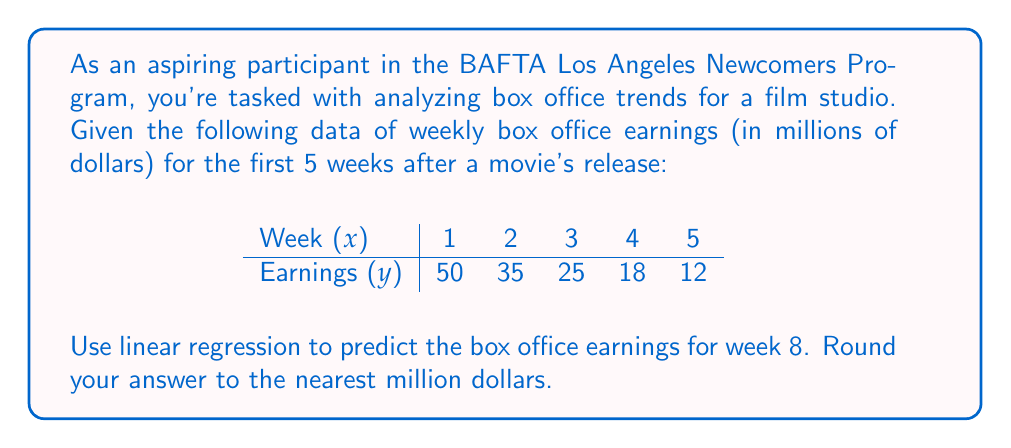Teach me how to tackle this problem. To solve this problem, we'll use linear regression to find the line of best fit and then use it to predict the earnings for week 8.

Step 1: Calculate the means of x and y
$\bar{x} = \frac{1+2+3+4+5}{5} = 3$
$\bar{y} = \frac{50+35+25+18+12}{5} = 28$

Step 2: Calculate the slope (m) using the formula:
$$m = \frac{\sum(x_i - \bar{x})(y_i - \bar{y})}{\sum(x_i - \bar{x})^2}$$

$\sum(x_i - \bar{x})(y_i - \bar{y}) = (1-3)(50-28) + (2-3)(35-28) + (3-3)(25-28) + (4-3)(18-28) + (5-3)(12-28) = -44 - 7 + 0 - 10 - 32 = -93$

$\sum(x_i - \bar{x})^2 = (1-3)^2 + (2-3)^2 + (3-3)^2 + (4-3)^2 + (5-3)^2 = 4 + 1 + 0 + 1 + 4 = 10$

$m = \frac{-93}{10} = -9.3$

Step 3: Calculate the y-intercept (b) using the formula:
$$b = \bar{y} - m\bar{x}$$

$b = 28 - (-9.3)(3) = 55.9$

Step 4: Write the equation of the line
$y = mx + b$
$y = -9.3x + 55.9$

Step 5: Predict the earnings for week 8
$y = -9.3(8) + 55.9 = 1.5$

Step 6: Round to the nearest million
1.5 rounds to 2 million dollars.
Answer: $2 million 